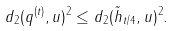Convert formula to latex. <formula><loc_0><loc_0><loc_500><loc_500>d _ { 2 } ( q ^ { ( t ) } , u ) ^ { 2 } \leq d _ { 2 } ( \tilde { h } _ { t / 4 } , u ) ^ { 2 } .</formula> 